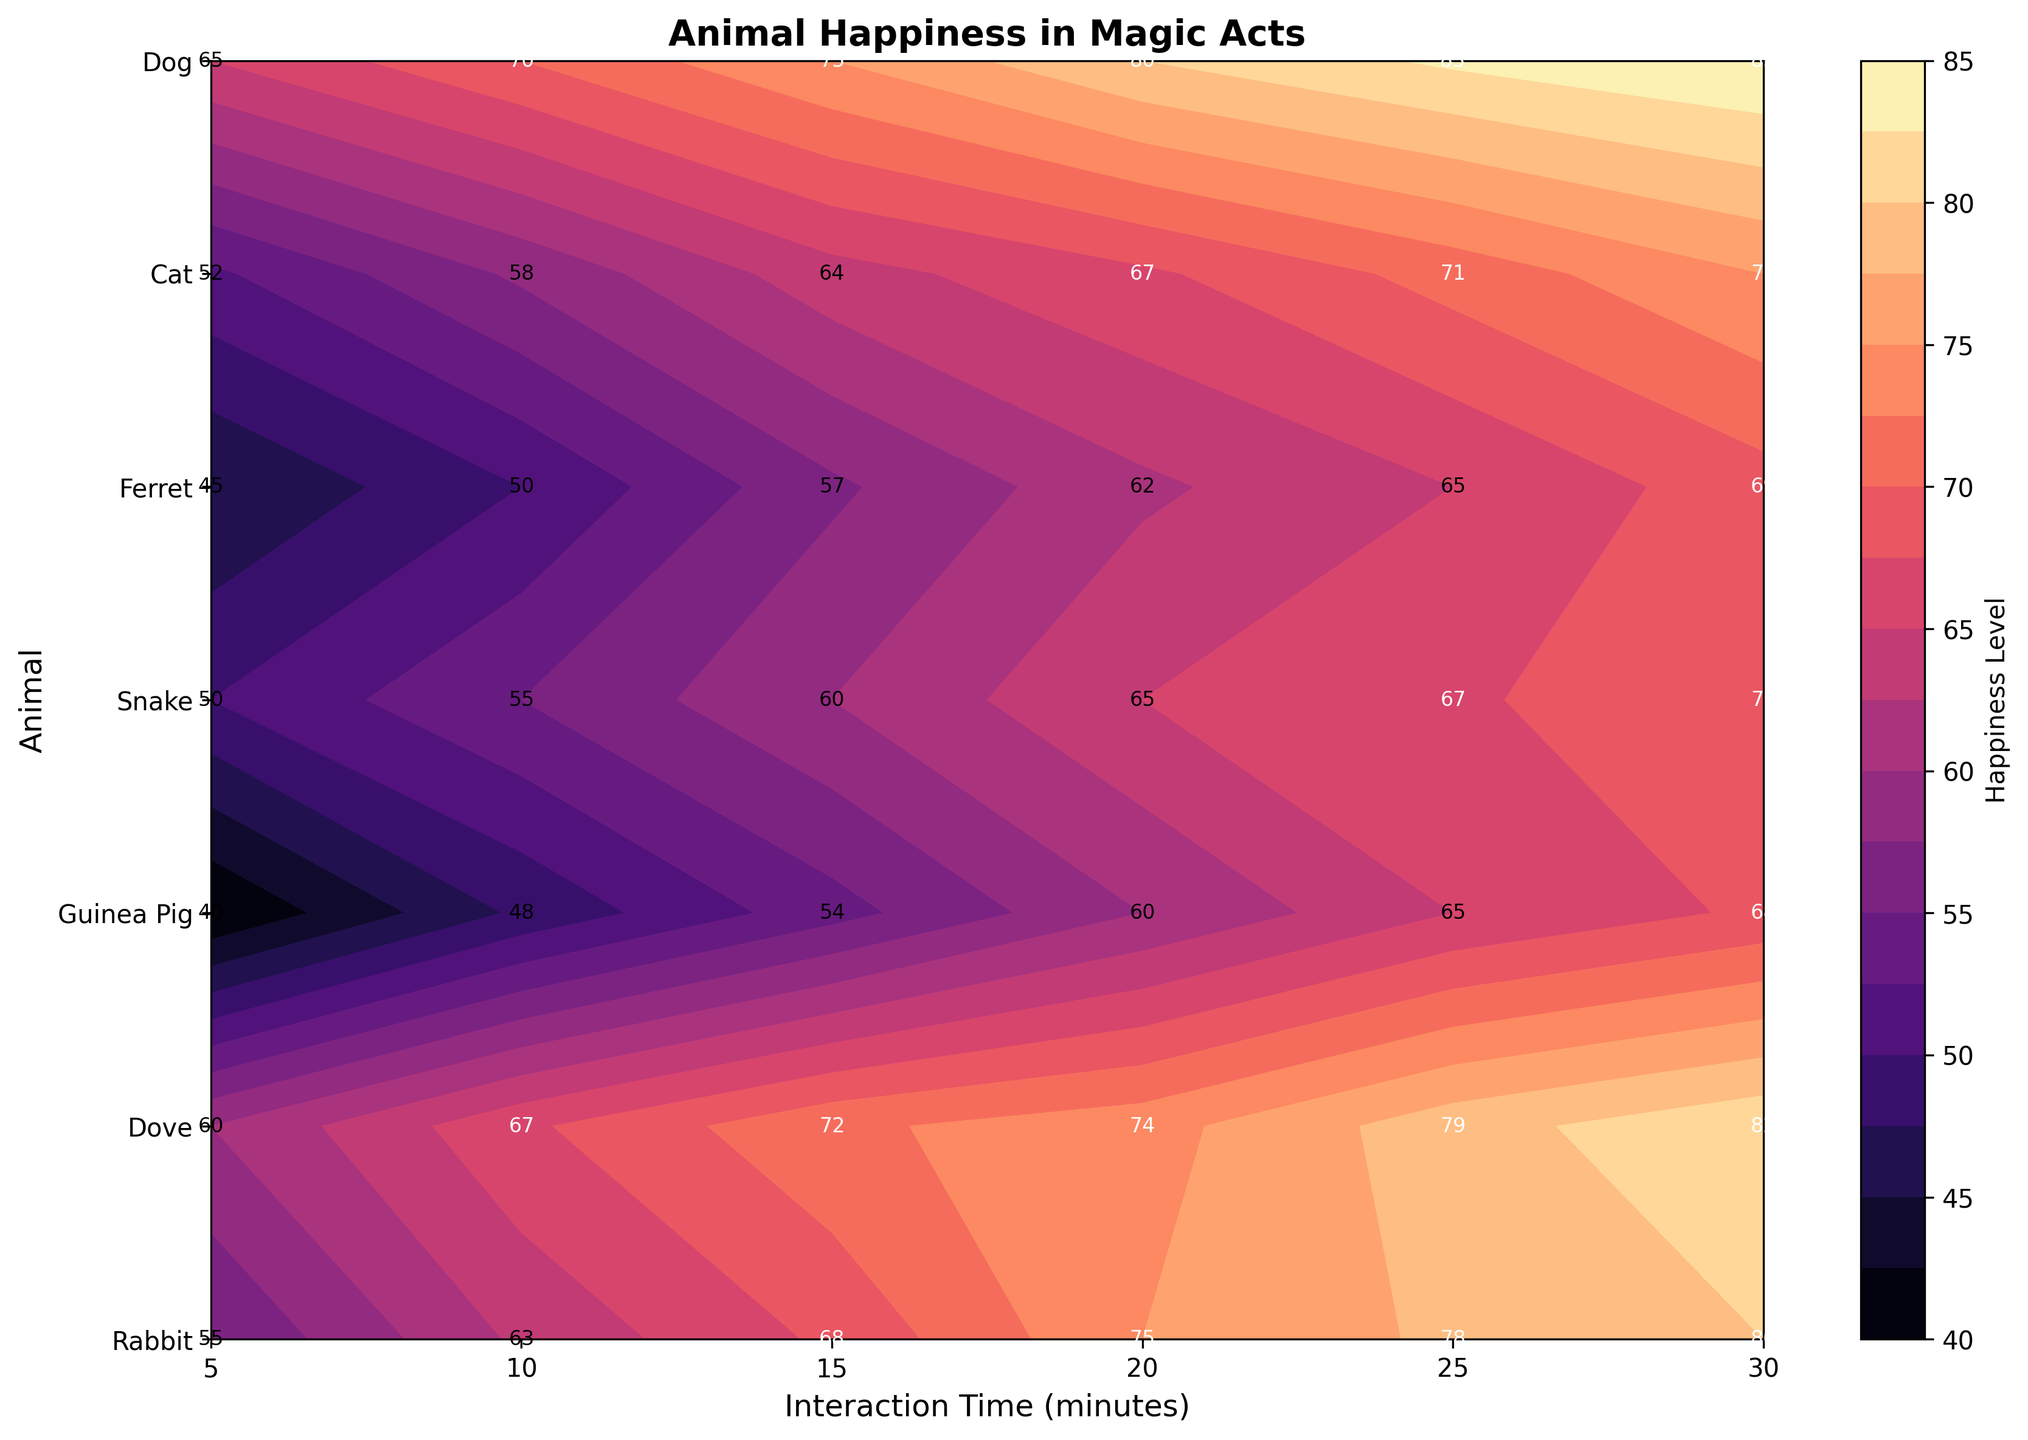What is the title of the figure? The title of the figure is located at the top of the plot and summarizes the contents of the plot. Here, it reads "Animal Happiness in Magic Acts."
Answer: Animal Happiness in Magic Acts How is the happiness level of doves changing with interaction time? To answer this, look at the contour plot lines and labels for the dove row. As interaction time increases from 5 to 30 minutes, the happiness level increases from 60 to 82.
Answer: It increases Which animal shows the highest happiness level at 30 minutes of interaction? To find this, locate the 30-minute column and check the happiness levels for all animals. The dog has the highest happiness level of 85.
Answer: Dog Compare the happiness levels of rabbits and guinea pigs at 20 minutes of interaction. Which animal is happier? Look at the happiness values for rabbits and guinea pigs at the 20-minute mark. Rabbits have a happiness level of 75, whereas guinea pigs have a happiness level of 60.
Answer: Rabbit What is the general trend observed for the happiness levels across all animals with increasing interaction time? By observing the contour plot, you can see that for all animals, happiness levels tend to increase as interaction time increases.
Answer: Happiness increases with time Which animal has the lowest happiness level at 10 minutes of interaction? To find this, locate the 10-minute column and find the lowest value. Guinea pigs have the lowest happiness level at 48.
Answer: Guinea Pig What is the average happiness level for ferrets at all measured interaction times? To find the average, sum the happiness levels for ferrets at all interaction times and divide by the number of times: (45 + 50 + 57 + 62 + 65 + 69) / 6 = 348 / 6.
Answer: 58 Among the listed animals, which has the smallest increase in happiness level from 5 to 30 minutes of interaction? Calculate the difference between the happiness levels at 5 and 30 minutes for each animal and compare. The snake's increase (70 - 50 = 20) is the smallest.
Answer: Snake Considering both 5-minute and 30-minute interaction times, which animal shows the maximum increase in happiness level? Compare the increase from 5 to 30 minutes for all animals. The dog shows the maximum increase (85 - 65 = 20).
Answer: Dog Which animals have a happiness level above 60 at both 5 minutes and 30 minutes of interaction? Check the happiness levels at 5 and 30 minutes for each animal. The animals that meet this criterion are: Dove, Dog, and Rabbit.
Answer: Dove, Dog, Rabbit 